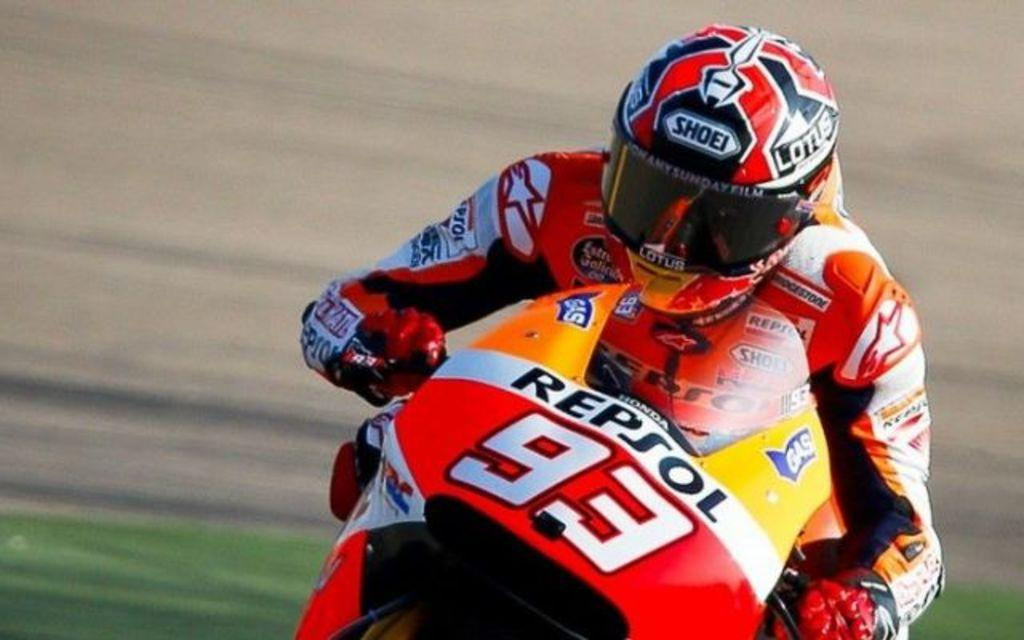What is the person in the image doing? The person is sitting on a bike in the image. What safety gear is the person wearing? The person is wearing a helmet and gloves. Where is the person riding the bike? The person is riding on a road. What can be seen beside the road? There is grassland beside the road. How many oranges are being held by the children in the image? There are no children or oranges present in the image. In which direction is the person riding the bike? The direction in which the person is riding the bike cannot be determined from the image. 